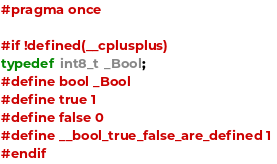<code> <loc_0><loc_0><loc_500><loc_500><_C_>#pragma once

#if !defined(__cplusplus)
typedef int8_t _Bool; 
#define bool _Bool
#define true 1
#define false 0
#define __bool_true_false_are_defined 1
#endif
</code> 